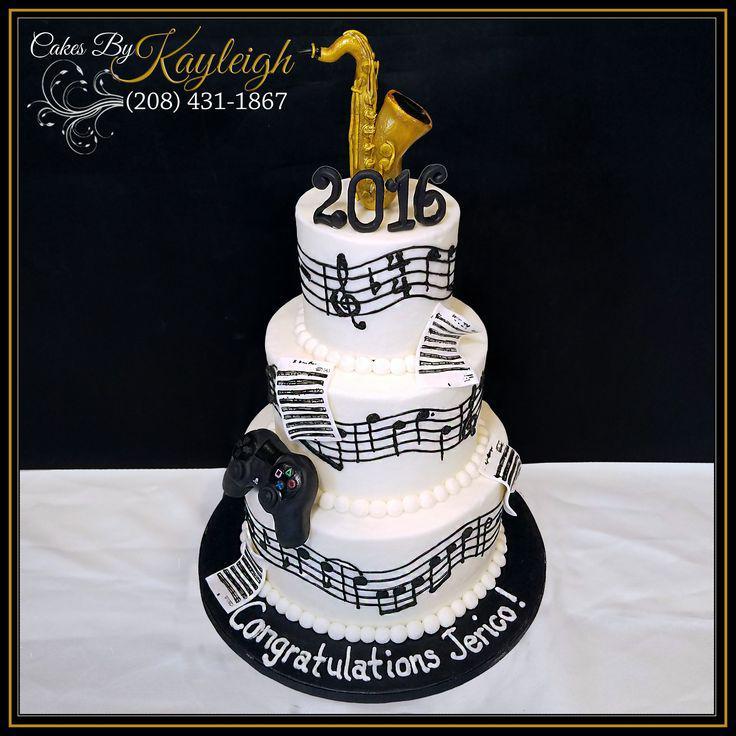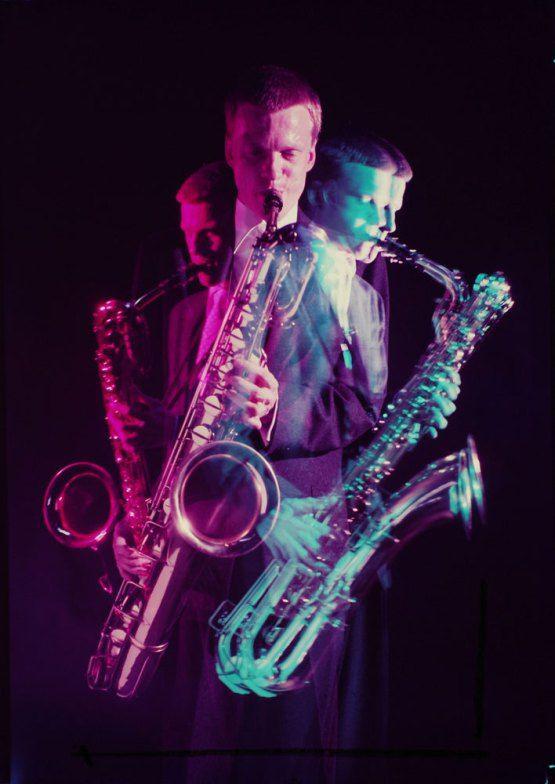The first image is the image on the left, the second image is the image on the right. Evaluate the accuracy of this statement regarding the images: "There are exactly two saxophones.". Is it true? Answer yes or no. No. 